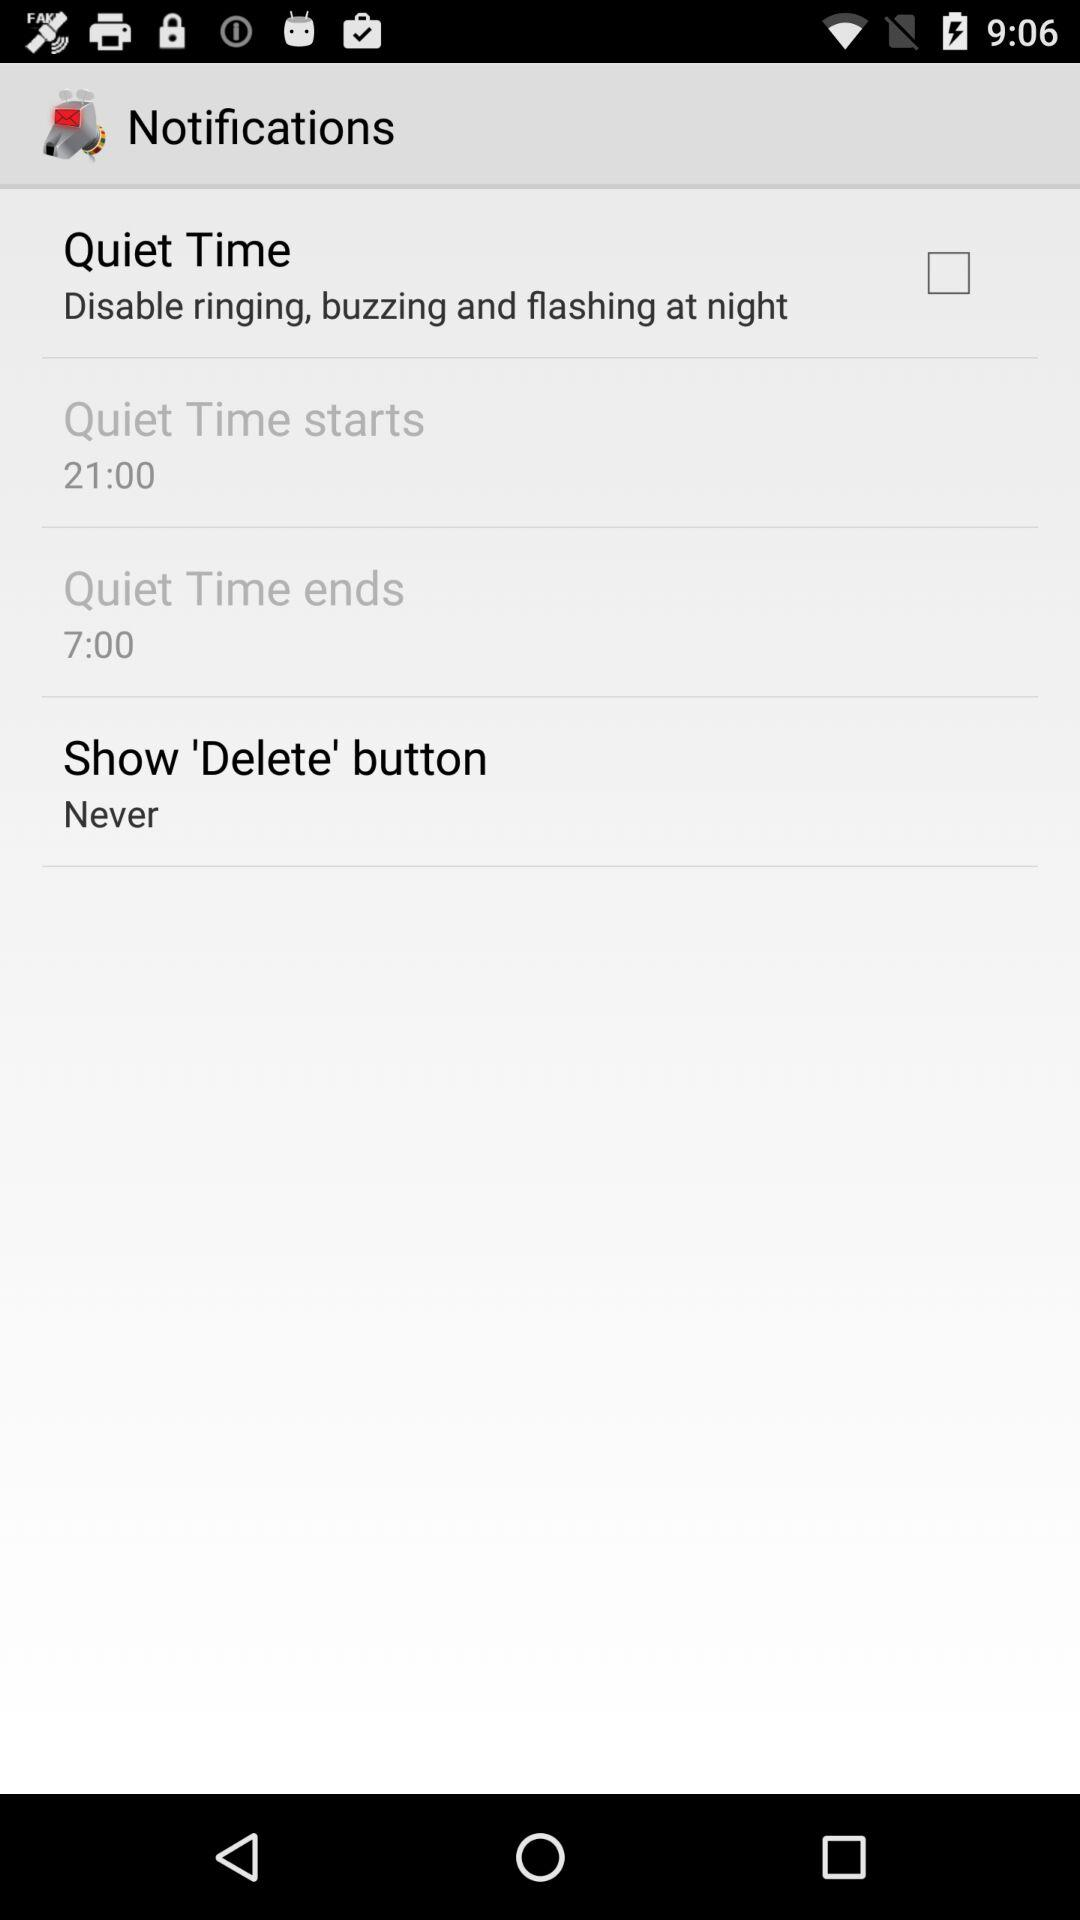When does the quiet time start? The quiet time starts at 21:00. 